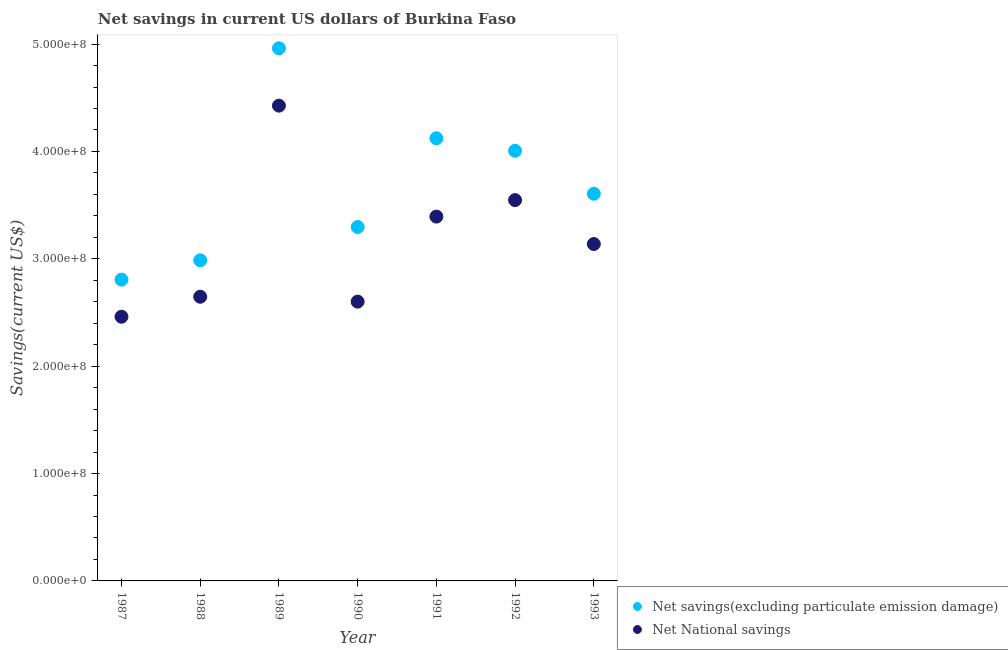What is the net savings(excluding particulate emission damage) in 1989?
Make the answer very short. 4.96e+08. Across all years, what is the maximum net savings(excluding particulate emission damage)?
Offer a very short reply. 4.96e+08. Across all years, what is the minimum net savings(excluding particulate emission damage)?
Your answer should be compact. 2.81e+08. What is the total net national savings in the graph?
Your answer should be compact. 2.22e+09. What is the difference between the net savings(excluding particulate emission damage) in 1988 and that in 1993?
Your answer should be compact. -6.20e+07. What is the difference between the net savings(excluding particulate emission damage) in 1987 and the net national savings in 1993?
Your answer should be very brief. -3.32e+07. What is the average net savings(excluding particulate emission damage) per year?
Offer a very short reply. 3.68e+08. In the year 1991, what is the difference between the net national savings and net savings(excluding particulate emission damage)?
Your response must be concise. -7.30e+07. In how many years, is the net national savings greater than 60000000 US$?
Your answer should be compact. 7. What is the ratio of the net national savings in 1990 to that in 1991?
Offer a very short reply. 0.77. Is the net national savings in 1989 less than that in 1990?
Your answer should be very brief. No. What is the difference between the highest and the second highest net savings(excluding particulate emission damage)?
Provide a succinct answer. 8.38e+07. What is the difference between the highest and the lowest net savings(excluding particulate emission damage)?
Provide a succinct answer. 2.15e+08. How many dotlines are there?
Your response must be concise. 2. What is the difference between two consecutive major ticks on the Y-axis?
Offer a very short reply. 1.00e+08. Does the graph contain any zero values?
Give a very brief answer. No. Does the graph contain grids?
Make the answer very short. No. Where does the legend appear in the graph?
Provide a short and direct response. Bottom right. How many legend labels are there?
Offer a very short reply. 2. What is the title of the graph?
Your answer should be very brief. Net savings in current US dollars of Burkina Faso. Does "Adolescent fertility rate" appear as one of the legend labels in the graph?
Ensure brevity in your answer.  No. What is the label or title of the Y-axis?
Offer a terse response. Savings(current US$). What is the Savings(current US$) of Net savings(excluding particulate emission damage) in 1987?
Give a very brief answer. 2.81e+08. What is the Savings(current US$) of Net National savings in 1987?
Provide a short and direct response. 2.46e+08. What is the Savings(current US$) of Net savings(excluding particulate emission damage) in 1988?
Your answer should be very brief. 2.99e+08. What is the Savings(current US$) of Net National savings in 1988?
Offer a very short reply. 2.65e+08. What is the Savings(current US$) of Net savings(excluding particulate emission damage) in 1989?
Your response must be concise. 4.96e+08. What is the Savings(current US$) in Net National savings in 1989?
Make the answer very short. 4.43e+08. What is the Savings(current US$) in Net savings(excluding particulate emission damage) in 1990?
Your response must be concise. 3.30e+08. What is the Savings(current US$) of Net National savings in 1990?
Offer a terse response. 2.60e+08. What is the Savings(current US$) in Net savings(excluding particulate emission damage) in 1991?
Make the answer very short. 4.12e+08. What is the Savings(current US$) of Net National savings in 1991?
Ensure brevity in your answer.  3.39e+08. What is the Savings(current US$) in Net savings(excluding particulate emission damage) in 1992?
Keep it short and to the point. 4.01e+08. What is the Savings(current US$) of Net National savings in 1992?
Your answer should be compact. 3.55e+08. What is the Savings(current US$) of Net savings(excluding particulate emission damage) in 1993?
Make the answer very short. 3.61e+08. What is the Savings(current US$) in Net National savings in 1993?
Ensure brevity in your answer.  3.14e+08. Across all years, what is the maximum Savings(current US$) of Net savings(excluding particulate emission damage)?
Your answer should be compact. 4.96e+08. Across all years, what is the maximum Savings(current US$) of Net National savings?
Ensure brevity in your answer.  4.43e+08. Across all years, what is the minimum Savings(current US$) in Net savings(excluding particulate emission damage)?
Offer a terse response. 2.81e+08. Across all years, what is the minimum Savings(current US$) in Net National savings?
Give a very brief answer. 2.46e+08. What is the total Savings(current US$) in Net savings(excluding particulate emission damage) in the graph?
Your answer should be compact. 2.58e+09. What is the total Savings(current US$) of Net National savings in the graph?
Your answer should be very brief. 2.22e+09. What is the difference between the Savings(current US$) in Net savings(excluding particulate emission damage) in 1987 and that in 1988?
Your answer should be very brief. -1.80e+07. What is the difference between the Savings(current US$) in Net National savings in 1987 and that in 1988?
Your answer should be very brief. -1.86e+07. What is the difference between the Savings(current US$) in Net savings(excluding particulate emission damage) in 1987 and that in 1989?
Provide a succinct answer. -2.15e+08. What is the difference between the Savings(current US$) of Net National savings in 1987 and that in 1989?
Your response must be concise. -1.97e+08. What is the difference between the Savings(current US$) in Net savings(excluding particulate emission damage) in 1987 and that in 1990?
Keep it short and to the point. -4.90e+07. What is the difference between the Savings(current US$) in Net National savings in 1987 and that in 1990?
Offer a terse response. -1.41e+07. What is the difference between the Savings(current US$) in Net savings(excluding particulate emission damage) in 1987 and that in 1991?
Ensure brevity in your answer.  -1.32e+08. What is the difference between the Savings(current US$) of Net National savings in 1987 and that in 1991?
Your answer should be compact. -9.33e+07. What is the difference between the Savings(current US$) in Net savings(excluding particulate emission damage) in 1987 and that in 1992?
Ensure brevity in your answer.  -1.20e+08. What is the difference between the Savings(current US$) of Net National savings in 1987 and that in 1992?
Ensure brevity in your answer.  -1.09e+08. What is the difference between the Savings(current US$) of Net savings(excluding particulate emission damage) in 1987 and that in 1993?
Your answer should be very brief. -8.00e+07. What is the difference between the Savings(current US$) in Net National savings in 1987 and that in 1993?
Keep it short and to the point. -6.77e+07. What is the difference between the Savings(current US$) of Net savings(excluding particulate emission damage) in 1988 and that in 1989?
Provide a succinct answer. -1.97e+08. What is the difference between the Savings(current US$) in Net National savings in 1988 and that in 1989?
Provide a succinct answer. -1.78e+08. What is the difference between the Savings(current US$) of Net savings(excluding particulate emission damage) in 1988 and that in 1990?
Offer a very short reply. -3.10e+07. What is the difference between the Savings(current US$) in Net National savings in 1988 and that in 1990?
Keep it short and to the point. 4.55e+06. What is the difference between the Savings(current US$) in Net savings(excluding particulate emission damage) in 1988 and that in 1991?
Ensure brevity in your answer.  -1.14e+08. What is the difference between the Savings(current US$) of Net National savings in 1988 and that in 1991?
Offer a very short reply. -7.47e+07. What is the difference between the Savings(current US$) of Net savings(excluding particulate emission damage) in 1988 and that in 1992?
Offer a terse response. -1.02e+08. What is the difference between the Savings(current US$) in Net National savings in 1988 and that in 1992?
Your answer should be compact. -9.00e+07. What is the difference between the Savings(current US$) of Net savings(excluding particulate emission damage) in 1988 and that in 1993?
Make the answer very short. -6.20e+07. What is the difference between the Savings(current US$) in Net National savings in 1988 and that in 1993?
Your answer should be very brief. -4.91e+07. What is the difference between the Savings(current US$) of Net savings(excluding particulate emission damage) in 1989 and that in 1990?
Make the answer very short. 1.66e+08. What is the difference between the Savings(current US$) in Net National savings in 1989 and that in 1990?
Provide a short and direct response. 1.83e+08. What is the difference between the Savings(current US$) in Net savings(excluding particulate emission damage) in 1989 and that in 1991?
Your response must be concise. 8.38e+07. What is the difference between the Savings(current US$) in Net National savings in 1989 and that in 1991?
Ensure brevity in your answer.  1.03e+08. What is the difference between the Savings(current US$) of Net savings(excluding particulate emission damage) in 1989 and that in 1992?
Provide a short and direct response. 9.54e+07. What is the difference between the Savings(current US$) of Net National savings in 1989 and that in 1992?
Give a very brief answer. 8.80e+07. What is the difference between the Savings(current US$) of Net savings(excluding particulate emission damage) in 1989 and that in 1993?
Your answer should be compact. 1.35e+08. What is the difference between the Savings(current US$) in Net National savings in 1989 and that in 1993?
Offer a very short reply. 1.29e+08. What is the difference between the Savings(current US$) in Net savings(excluding particulate emission damage) in 1990 and that in 1991?
Your answer should be compact. -8.27e+07. What is the difference between the Savings(current US$) in Net National savings in 1990 and that in 1991?
Make the answer very short. -7.92e+07. What is the difference between the Savings(current US$) in Net savings(excluding particulate emission damage) in 1990 and that in 1992?
Your answer should be compact. -7.10e+07. What is the difference between the Savings(current US$) of Net National savings in 1990 and that in 1992?
Provide a short and direct response. -9.45e+07. What is the difference between the Savings(current US$) of Net savings(excluding particulate emission damage) in 1990 and that in 1993?
Provide a short and direct response. -3.10e+07. What is the difference between the Savings(current US$) in Net National savings in 1990 and that in 1993?
Offer a very short reply. -5.37e+07. What is the difference between the Savings(current US$) in Net savings(excluding particulate emission damage) in 1991 and that in 1992?
Give a very brief answer. 1.16e+07. What is the difference between the Savings(current US$) of Net National savings in 1991 and that in 1992?
Your answer should be very brief. -1.53e+07. What is the difference between the Savings(current US$) in Net savings(excluding particulate emission damage) in 1991 and that in 1993?
Provide a succinct answer. 5.17e+07. What is the difference between the Savings(current US$) of Net National savings in 1991 and that in 1993?
Your response must be concise. 2.55e+07. What is the difference between the Savings(current US$) in Net savings(excluding particulate emission damage) in 1992 and that in 1993?
Make the answer very short. 4.00e+07. What is the difference between the Savings(current US$) in Net National savings in 1992 and that in 1993?
Make the answer very short. 4.09e+07. What is the difference between the Savings(current US$) in Net savings(excluding particulate emission damage) in 1987 and the Savings(current US$) in Net National savings in 1988?
Give a very brief answer. 1.59e+07. What is the difference between the Savings(current US$) of Net savings(excluding particulate emission damage) in 1987 and the Savings(current US$) of Net National savings in 1989?
Provide a succinct answer. -1.62e+08. What is the difference between the Savings(current US$) in Net savings(excluding particulate emission damage) in 1987 and the Savings(current US$) in Net National savings in 1990?
Your answer should be compact. 2.05e+07. What is the difference between the Savings(current US$) of Net savings(excluding particulate emission damage) in 1987 and the Savings(current US$) of Net National savings in 1991?
Give a very brief answer. -5.87e+07. What is the difference between the Savings(current US$) of Net savings(excluding particulate emission damage) in 1987 and the Savings(current US$) of Net National savings in 1992?
Offer a very short reply. -7.41e+07. What is the difference between the Savings(current US$) of Net savings(excluding particulate emission damage) in 1987 and the Savings(current US$) of Net National savings in 1993?
Give a very brief answer. -3.32e+07. What is the difference between the Savings(current US$) of Net savings(excluding particulate emission damage) in 1988 and the Savings(current US$) of Net National savings in 1989?
Keep it short and to the point. -1.44e+08. What is the difference between the Savings(current US$) of Net savings(excluding particulate emission damage) in 1988 and the Savings(current US$) of Net National savings in 1990?
Offer a terse response. 3.85e+07. What is the difference between the Savings(current US$) of Net savings(excluding particulate emission damage) in 1988 and the Savings(current US$) of Net National savings in 1991?
Keep it short and to the point. -4.07e+07. What is the difference between the Savings(current US$) in Net savings(excluding particulate emission damage) in 1988 and the Savings(current US$) in Net National savings in 1992?
Offer a very short reply. -5.60e+07. What is the difference between the Savings(current US$) of Net savings(excluding particulate emission damage) in 1988 and the Savings(current US$) of Net National savings in 1993?
Offer a very short reply. -1.51e+07. What is the difference between the Savings(current US$) of Net savings(excluding particulate emission damage) in 1989 and the Savings(current US$) of Net National savings in 1990?
Your answer should be very brief. 2.36e+08. What is the difference between the Savings(current US$) of Net savings(excluding particulate emission damage) in 1989 and the Savings(current US$) of Net National savings in 1991?
Ensure brevity in your answer.  1.57e+08. What is the difference between the Savings(current US$) in Net savings(excluding particulate emission damage) in 1989 and the Savings(current US$) in Net National savings in 1992?
Offer a very short reply. 1.41e+08. What is the difference between the Savings(current US$) in Net savings(excluding particulate emission damage) in 1989 and the Savings(current US$) in Net National savings in 1993?
Ensure brevity in your answer.  1.82e+08. What is the difference between the Savings(current US$) in Net savings(excluding particulate emission damage) in 1990 and the Savings(current US$) in Net National savings in 1991?
Your response must be concise. -9.70e+06. What is the difference between the Savings(current US$) of Net savings(excluding particulate emission damage) in 1990 and the Savings(current US$) of Net National savings in 1992?
Provide a succinct answer. -2.50e+07. What is the difference between the Savings(current US$) of Net savings(excluding particulate emission damage) in 1990 and the Savings(current US$) of Net National savings in 1993?
Your answer should be compact. 1.58e+07. What is the difference between the Savings(current US$) of Net savings(excluding particulate emission damage) in 1991 and the Savings(current US$) of Net National savings in 1992?
Ensure brevity in your answer.  5.76e+07. What is the difference between the Savings(current US$) of Net savings(excluding particulate emission damage) in 1991 and the Savings(current US$) of Net National savings in 1993?
Your answer should be very brief. 9.85e+07. What is the difference between the Savings(current US$) of Net savings(excluding particulate emission damage) in 1992 and the Savings(current US$) of Net National savings in 1993?
Give a very brief answer. 8.69e+07. What is the average Savings(current US$) of Net savings(excluding particulate emission damage) per year?
Provide a short and direct response. 3.68e+08. What is the average Savings(current US$) of Net National savings per year?
Your answer should be compact. 3.17e+08. In the year 1987, what is the difference between the Savings(current US$) of Net savings(excluding particulate emission damage) and Savings(current US$) of Net National savings?
Keep it short and to the point. 3.45e+07. In the year 1988, what is the difference between the Savings(current US$) of Net savings(excluding particulate emission damage) and Savings(current US$) of Net National savings?
Offer a very short reply. 3.40e+07. In the year 1989, what is the difference between the Savings(current US$) of Net savings(excluding particulate emission damage) and Savings(current US$) of Net National savings?
Offer a terse response. 5.34e+07. In the year 1990, what is the difference between the Savings(current US$) of Net savings(excluding particulate emission damage) and Savings(current US$) of Net National savings?
Your answer should be very brief. 6.95e+07. In the year 1991, what is the difference between the Savings(current US$) in Net savings(excluding particulate emission damage) and Savings(current US$) in Net National savings?
Your answer should be compact. 7.30e+07. In the year 1992, what is the difference between the Savings(current US$) in Net savings(excluding particulate emission damage) and Savings(current US$) in Net National savings?
Offer a terse response. 4.60e+07. In the year 1993, what is the difference between the Savings(current US$) of Net savings(excluding particulate emission damage) and Savings(current US$) of Net National savings?
Your answer should be compact. 4.69e+07. What is the ratio of the Savings(current US$) in Net savings(excluding particulate emission damage) in 1987 to that in 1988?
Make the answer very short. 0.94. What is the ratio of the Savings(current US$) in Net National savings in 1987 to that in 1988?
Give a very brief answer. 0.93. What is the ratio of the Savings(current US$) of Net savings(excluding particulate emission damage) in 1987 to that in 1989?
Give a very brief answer. 0.57. What is the ratio of the Savings(current US$) of Net National savings in 1987 to that in 1989?
Offer a very short reply. 0.56. What is the ratio of the Savings(current US$) in Net savings(excluding particulate emission damage) in 1987 to that in 1990?
Your answer should be very brief. 0.85. What is the ratio of the Savings(current US$) of Net National savings in 1987 to that in 1990?
Keep it short and to the point. 0.95. What is the ratio of the Savings(current US$) of Net savings(excluding particulate emission damage) in 1987 to that in 1991?
Provide a short and direct response. 0.68. What is the ratio of the Savings(current US$) in Net National savings in 1987 to that in 1991?
Ensure brevity in your answer.  0.73. What is the ratio of the Savings(current US$) in Net savings(excluding particulate emission damage) in 1987 to that in 1992?
Keep it short and to the point. 0.7. What is the ratio of the Savings(current US$) of Net National savings in 1987 to that in 1992?
Provide a succinct answer. 0.69. What is the ratio of the Savings(current US$) of Net savings(excluding particulate emission damage) in 1987 to that in 1993?
Your answer should be compact. 0.78. What is the ratio of the Savings(current US$) of Net National savings in 1987 to that in 1993?
Provide a succinct answer. 0.78. What is the ratio of the Savings(current US$) of Net savings(excluding particulate emission damage) in 1988 to that in 1989?
Provide a short and direct response. 0.6. What is the ratio of the Savings(current US$) of Net National savings in 1988 to that in 1989?
Make the answer very short. 0.6. What is the ratio of the Savings(current US$) in Net savings(excluding particulate emission damage) in 1988 to that in 1990?
Provide a succinct answer. 0.91. What is the ratio of the Savings(current US$) of Net National savings in 1988 to that in 1990?
Make the answer very short. 1.02. What is the ratio of the Savings(current US$) in Net savings(excluding particulate emission damage) in 1988 to that in 1991?
Your answer should be very brief. 0.72. What is the ratio of the Savings(current US$) in Net National savings in 1988 to that in 1991?
Ensure brevity in your answer.  0.78. What is the ratio of the Savings(current US$) of Net savings(excluding particulate emission damage) in 1988 to that in 1992?
Make the answer very short. 0.75. What is the ratio of the Savings(current US$) in Net National savings in 1988 to that in 1992?
Keep it short and to the point. 0.75. What is the ratio of the Savings(current US$) in Net savings(excluding particulate emission damage) in 1988 to that in 1993?
Keep it short and to the point. 0.83. What is the ratio of the Savings(current US$) of Net National savings in 1988 to that in 1993?
Give a very brief answer. 0.84. What is the ratio of the Savings(current US$) of Net savings(excluding particulate emission damage) in 1989 to that in 1990?
Your answer should be compact. 1.5. What is the ratio of the Savings(current US$) in Net National savings in 1989 to that in 1990?
Provide a succinct answer. 1.7. What is the ratio of the Savings(current US$) of Net savings(excluding particulate emission damage) in 1989 to that in 1991?
Keep it short and to the point. 1.2. What is the ratio of the Savings(current US$) in Net National savings in 1989 to that in 1991?
Your response must be concise. 1.3. What is the ratio of the Savings(current US$) in Net savings(excluding particulate emission damage) in 1989 to that in 1992?
Your response must be concise. 1.24. What is the ratio of the Savings(current US$) of Net National savings in 1989 to that in 1992?
Your answer should be very brief. 1.25. What is the ratio of the Savings(current US$) in Net savings(excluding particulate emission damage) in 1989 to that in 1993?
Your answer should be compact. 1.38. What is the ratio of the Savings(current US$) of Net National savings in 1989 to that in 1993?
Provide a short and direct response. 1.41. What is the ratio of the Savings(current US$) in Net savings(excluding particulate emission damage) in 1990 to that in 1991?
Offer a very short reply. 0.8. What is the ratio of the Savings(current US$) of Net National savings in 1990 to that in 1991?
Provide a succinct answer. 0.77. What is the ratio of the Savings(current US$) of Net savings(excluding particulate emission damage) in 1990 to that in 1992?
Offer a terse response. 0.82. What is the ratio of the Savings(current US$) in Net National savings in 1990 to that in 1992?
Provide a short and direct response. 0.73. What is the ratio of the Savings(current US$) in Net savings(excluding particulate emission damage) in 1990 to that in 1993?
Keep it short and to the point. 0.91. What is the ratio of the Savings(current US$) of Net National savings in 1990 to that in 1993?
Provide a short and direct response. 0.83. What is the ratio of the Savings(current US$) in Net savings(excluding particulate emission damage) in 1991 to that in 1992?
Your response must be concise. 1.03. What is the ratio of the Savings(current US$) of Net National savings in 1991 to that in 1992?
Your answer should be very brief. 0.96. What is the ratio of the Savings(current US$) in Net savings(excluding particulate emission damage) in 1991 to that in 1993?
Your answer should be very brief. 1.14. What is the ratio of the Savings(current US$) in Net National savings in 1991 to that in 1993?
Offer a terse response. 1.08. What is the ratio of the Savings(current US$) in Net savings(excluding particulate emission damage) in 1992 to that in 1993?
Offer a terse response. 1.11. What is the ratio of the Savings(current US$) in Net National savings in 1992 to that in 1993?
Ensure brevity in your answer.  1.13. What is the difference between the highest and the second highest Savings(current US$) in Net savings(excluding particulate emission damage)?
Give a very brief answer. 8.38e+07. What is the difference between the highest and the second highest Savings(current US$) of Net National savings?
Offer a terse response. 8.80e+07. What is the difference between the highest and the lowest Savings(current US$) in Net savings(excluding particulate emission damage)?
Keep it short and to the point. 2.15e+08. What is the difference between the highest and the lowest Savings(current US$) in Net National savings?
Your answer should be very brief. 1.97e+08. 